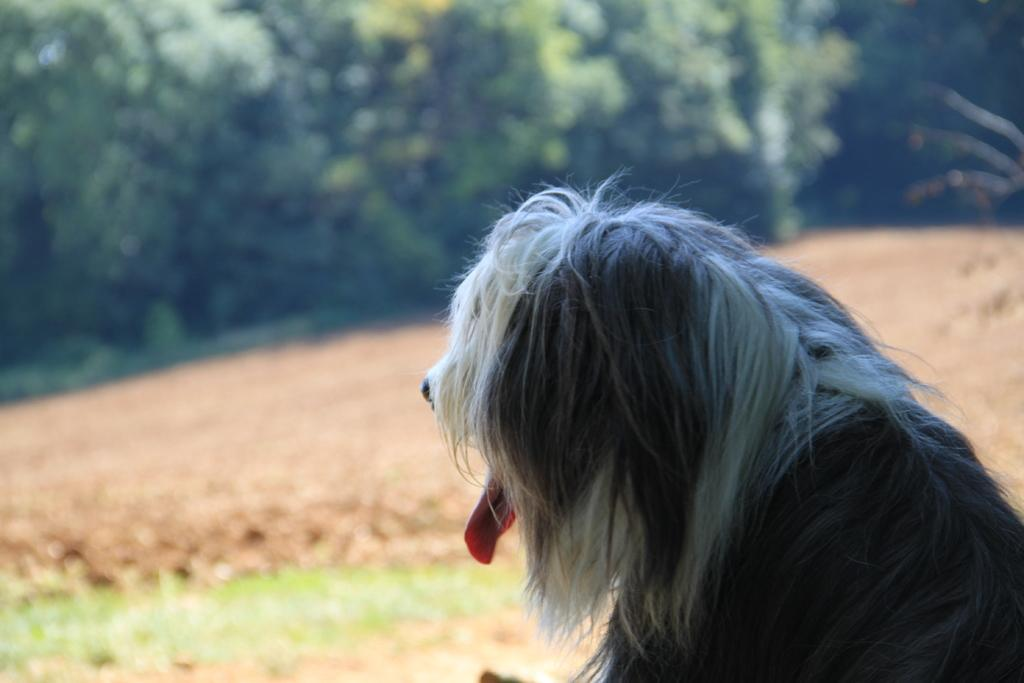What type of animal is in the image? There is a dog in the image. Where is the dog located in the image? The dog is on the ground. What type of vegetation is visible in the image? There are trees and plants in the image. What is the ground covered with in the image? There is grass on the ground in the image. What grade is the dog in the image? The dog is not in a grade, as it is an animal and not a student. What letter does the dog spell out in the image? The dog does not spell out any letters in the image; it is a living animal. 